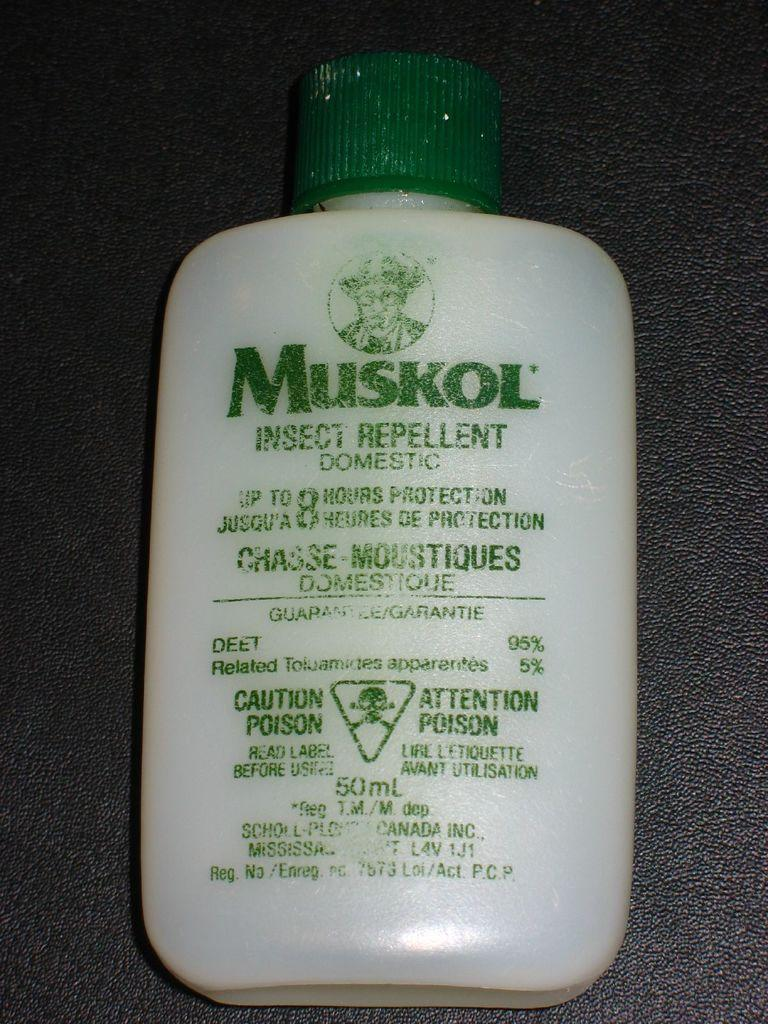<image>
Write a terse but informative summary of the picture. A bottle has the brand name Muskol on it. 